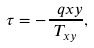<formula> <loc_0><loc_0><loc_500><loc_500>\tau = - \frac { \ q x y } { T _ { x y } } ,</formula> 